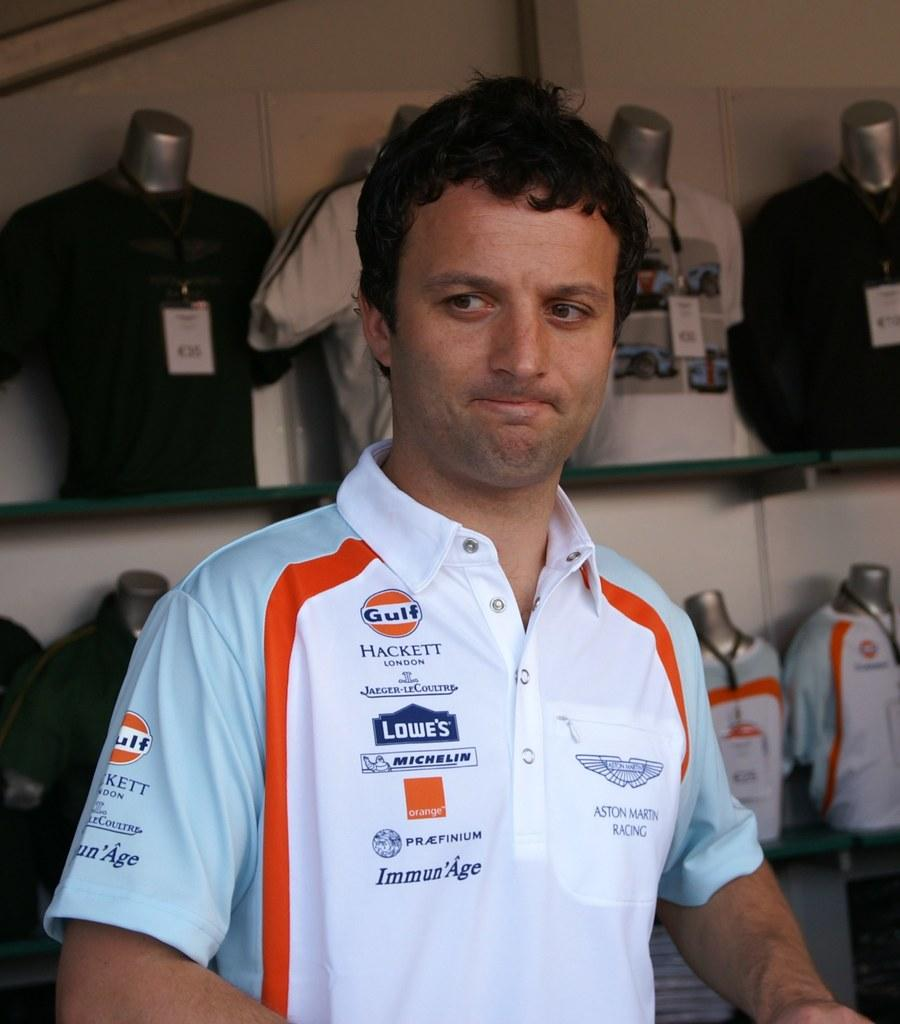<image>
Render a clear and concise summary of the photo. Aston Martin Racing is patched onto this competitor's shirt. 